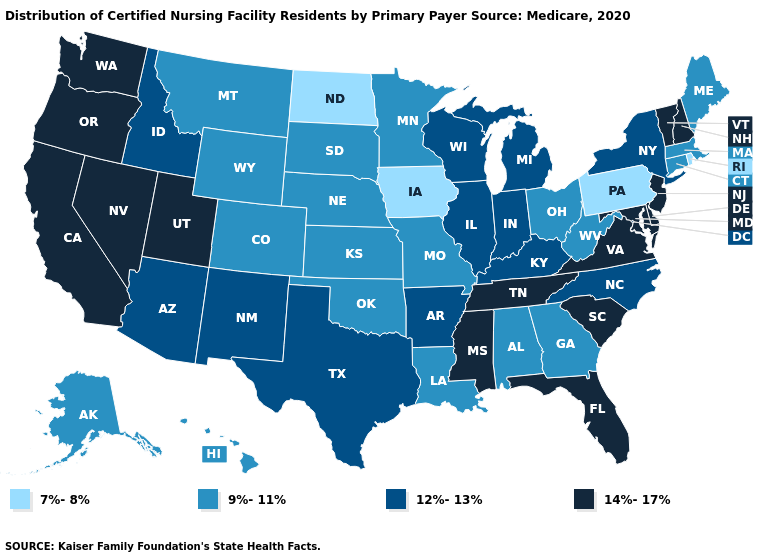Does California have the highest value in the West?
Give a very brief answer. Yes. What is the value of West Virginia?
Keep it brief. 9%-11%. Name the states that have a value in the range 7%-8%?
Write a very short answer. Iowa, North Dakota, Pennsylvania, Rhode Island. What is the lowest value in the West?
Concise answer only. 9%-11%. Name the states that have a value in the range 7%-8%?
Short answer required. Iowa, North Dakota, Pennsylvania, Rhode Island. What is the lowest value in the USA?
Short answer required. 7%-8%. What is the value of New Jersey?
Give a very brief answer. 14%-17%. Name the states that have a value in the range 7%-8%?
Concise answer only. Iowa, North Dakota, Pennsylvania, Rhode Island. What is the value of Illinois?
Concise answer only. 12%-13%. Name the states that have a value in the range 12%-13%?
Answer briefly. Arizona, Arkansas, Idaho, Illinois, Indiana, Kentucky, Michigan, New Mexico, New York, North Carolina, Texas, Wisconsin. What is the value of Hawaii?
Keep it brief. 9%-11%. What is the value of Utah?
Write a very short answer. 14%-17%. What is the value of South Dakota?
Keep it brief. 9%-11%. 